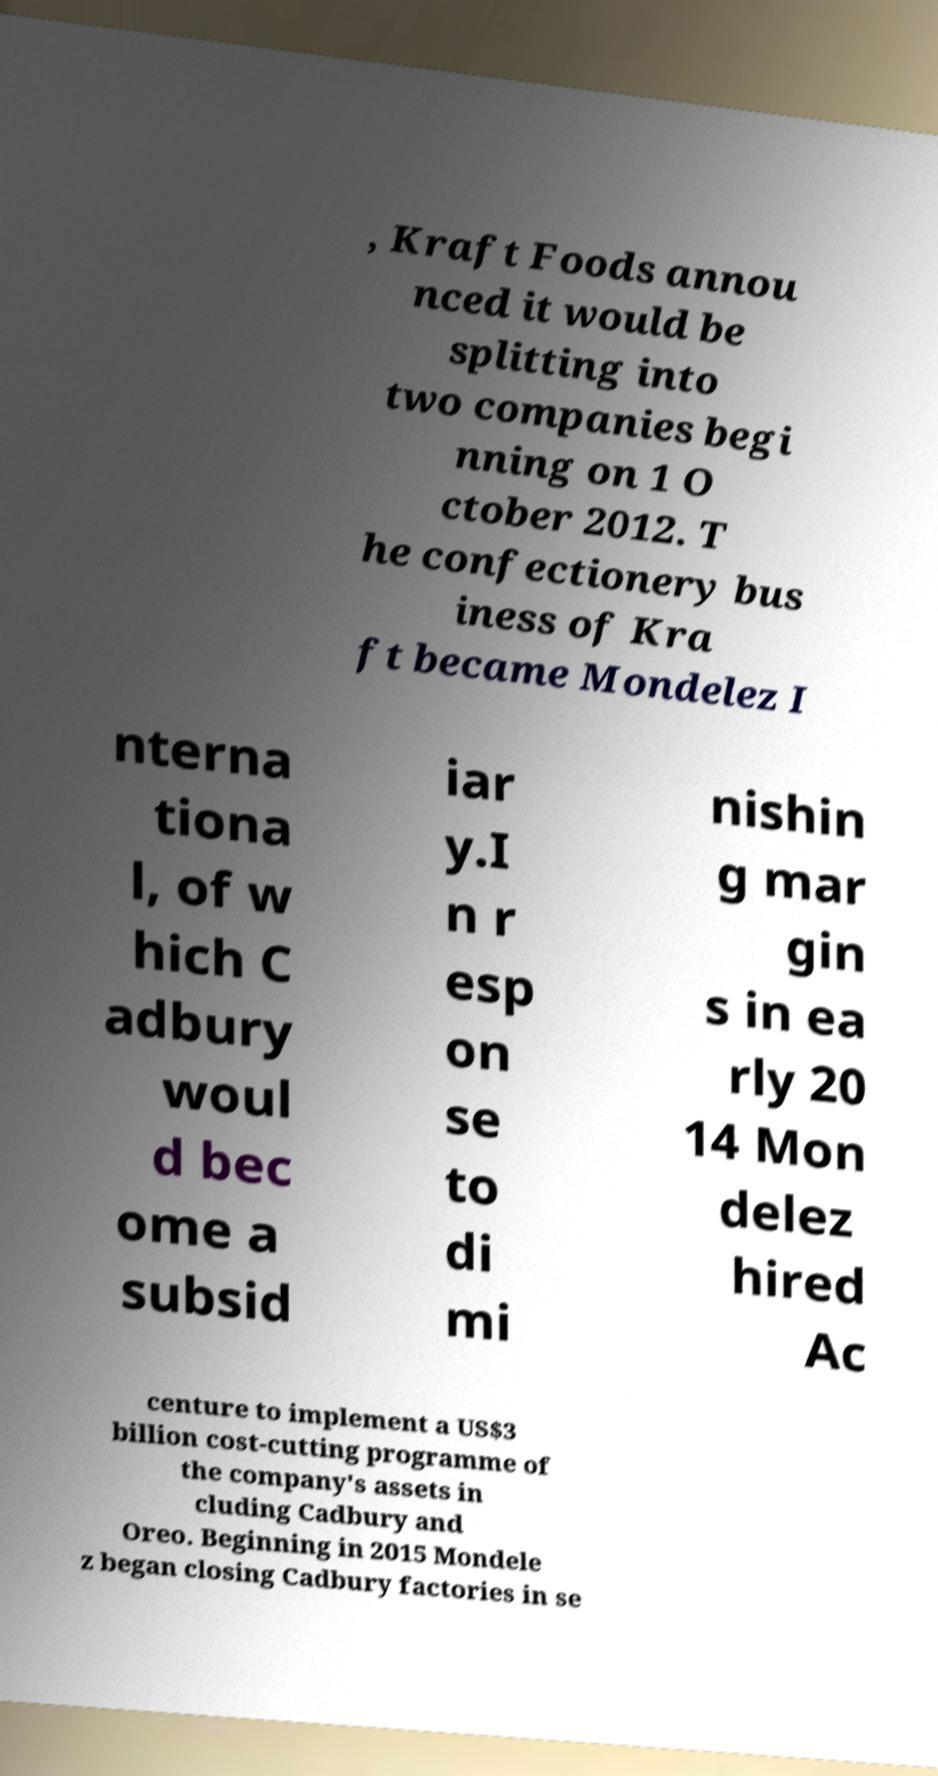There's text embedded in this image that I need extracted. Can you transcribe it verbatim? , Kraft Foods annou nced it would be splitting into two companies begi nning on 1 O ctober 2012. T he confectionery bus iness of Kra ft became Mondelez I nterna tiona l, of w hich C adbury woul d bec ome a subsid iar y.I n r esp on se to di mi nishin g mar gin s in ea rly 20 14 Mon delez hired Ac centure to implement a US$3 billion cost-cutting programme of the company's assets in cluding Cadbury and Oreo. Beginning in 2015 Mondele z began closing Cadbury factories in se 